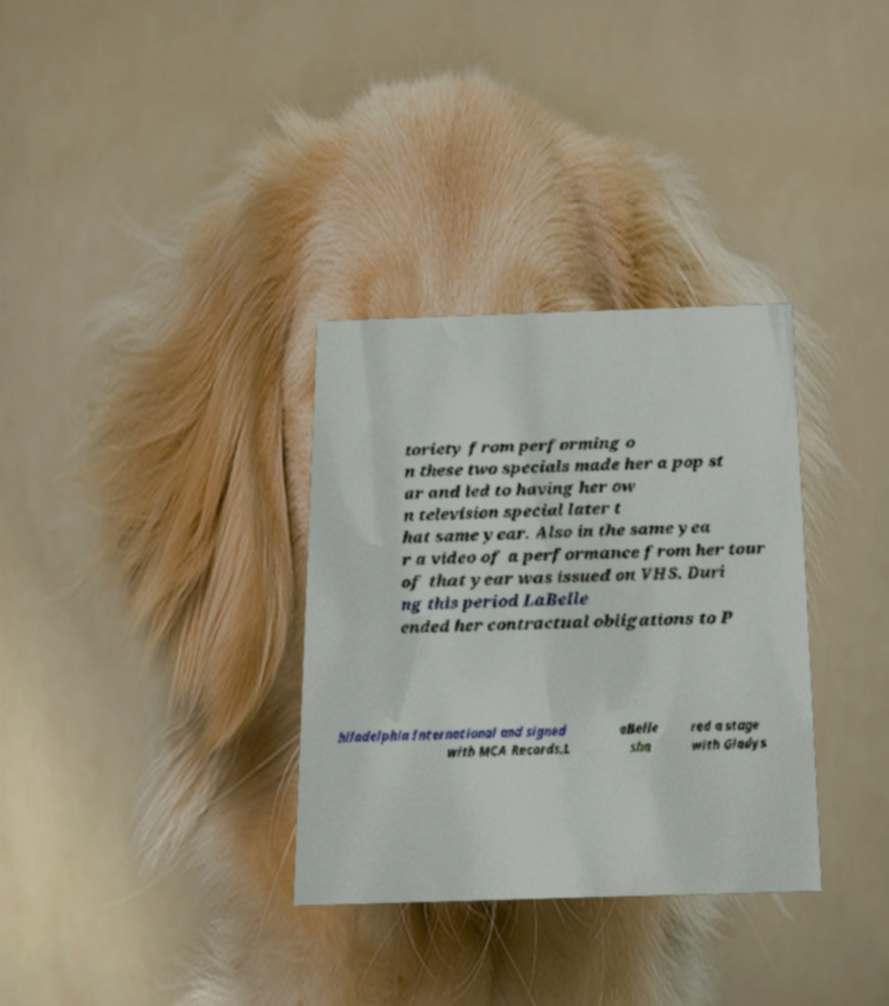Could you extract and type out the text from this image? toriety from performing o n these two specials made her a pop st ar and led to having her ow n television special later t hat same year. Also in the same yea r a video of a performance from her tour of that year was issued on VHS. Duri ng this period LaBelle ended her contractual obligations to P hiladelphia International and signed with MCA Records.L aBelle sha red a stage with Gladys 